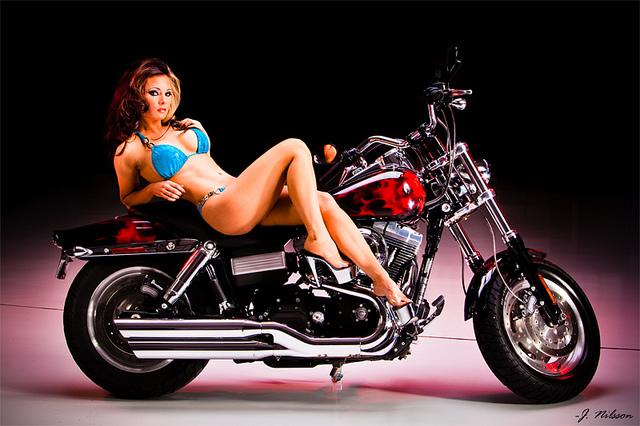Is the woman riding the motorcycle?
Be succinct. No. What is the woman wearing?
Quick response, please. Bikini. Would it be safe to ride a motorcycle dressed like this?
Concise answer only. No. 